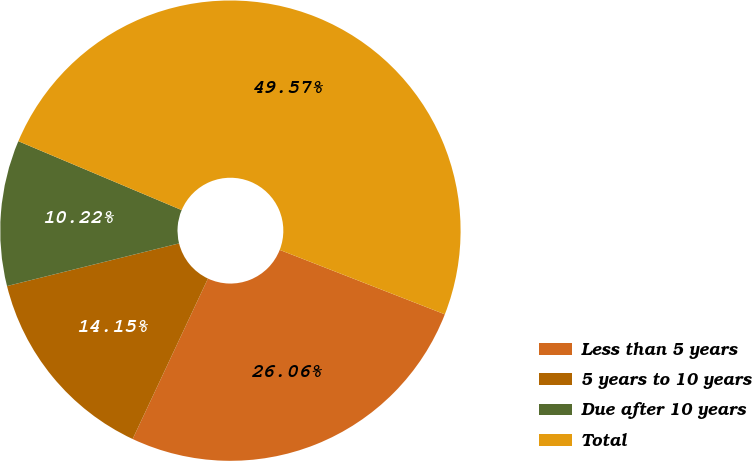Convert chart to OTSL. <chart><loc_0><loc_0><loc_500><loc_500><pie_chart><fcel>Less than 5 years<fcel>5 years to 10 years<fcel>Due after 10 years<fcel>Total<nl><fcel>26.06%<fcel>14.15%<fcel>10.22%<fcel>49.57%<nl></chart> 